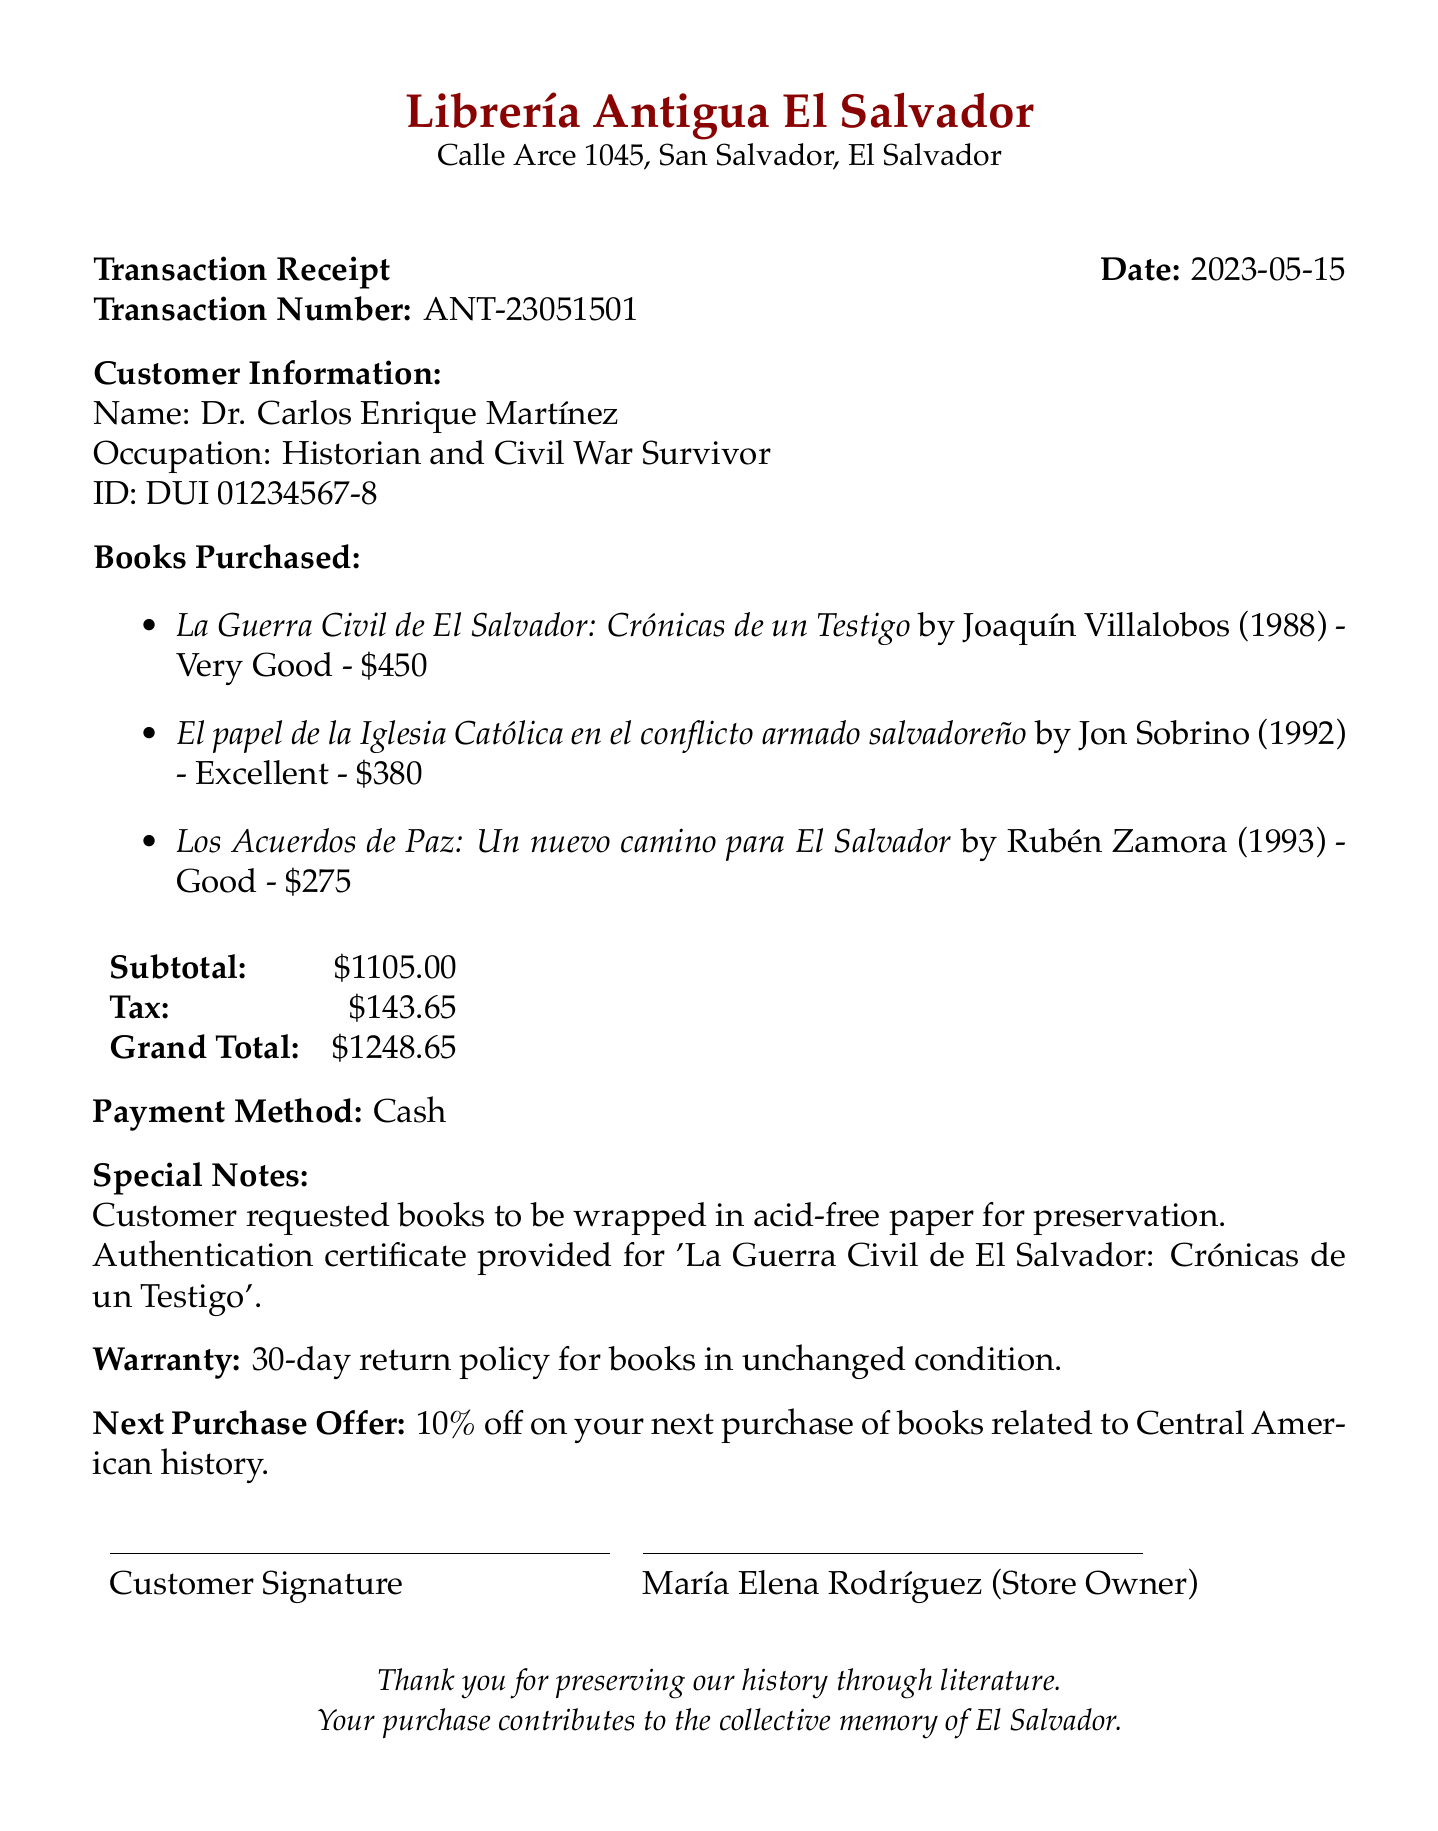What is the bookstore's name? The bookstore's name is stated clearly at the top of the document.
Answer: Librería Antigua El Salvador Who is the bookstore owner? The document specifies the owner of the bookstore in the corresponding section.
Answer: María Elena Rodríguez When was the transaction made? The date of the transaction is mentioned in the heading of the receipt.
Answer: 2023-05-15 What is the total price of the books purchased? The total price is summarized in the financial section of the document.
Answer: $1105 What payment method was used? The method of payment is detailed in the document.
Answer: Cash What is the warranty period for the books? The warranty information is explicitly stated in the document.
Answer: 30-day return policy What discount is offered for the next purchase? The next purchase offer is included in the notes section of the document.
Answer: 10% off Which book comes with an authentication certificate? The document mentions that one of the purchased books has an additional service of authentication.
Answer: La Guerra Civil de El Salvador: Crónicas de un Testigo What is the tax amount included in the total? The tax amount is clearly indicated in the financial summary.
Answer: $143.65 